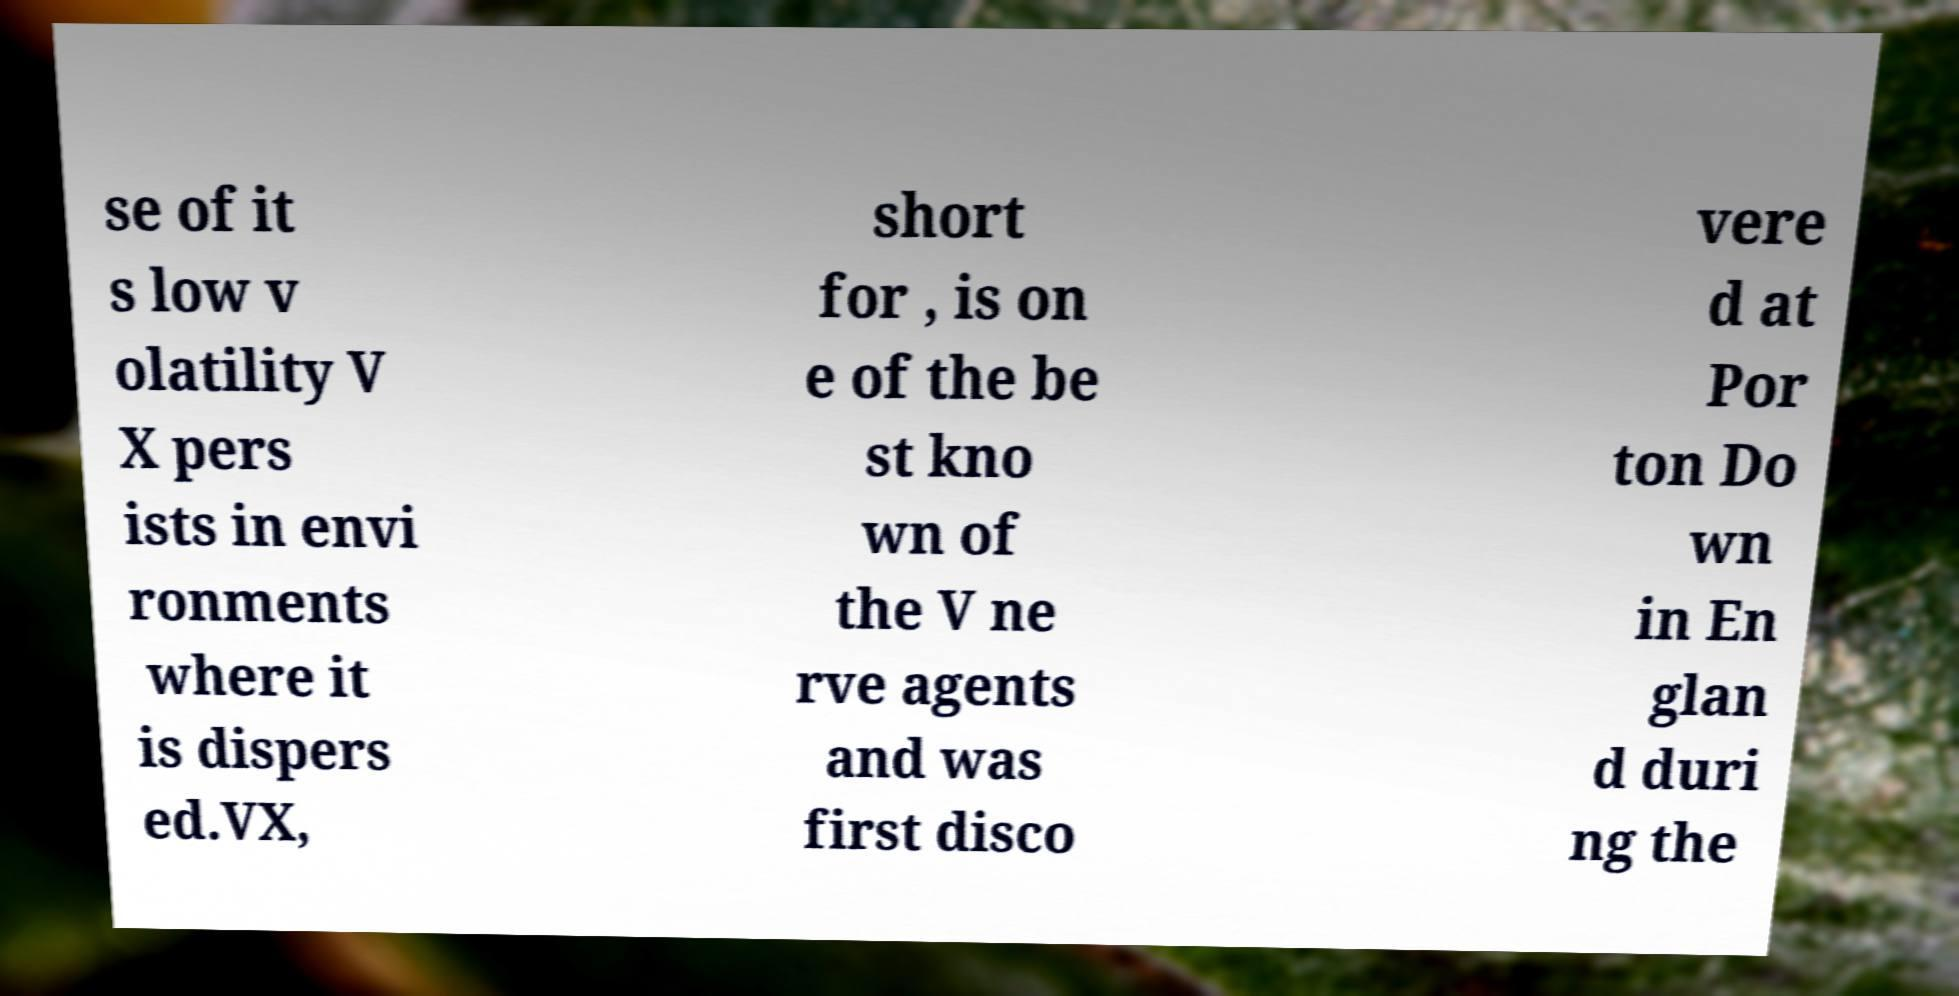Please identify and transcribe the text found in this image. se of it s low v olatility V X pers ists in envi ronments where it is dispers ed.VX, short for , is on e of the be st kno wn of the V ne rve agents and was first disco vere d at Por ton Do wn in En glan d duri ng the 